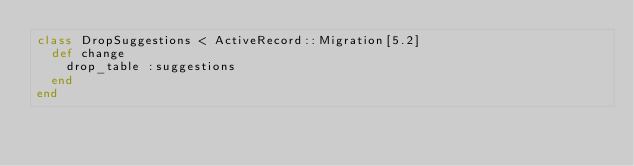<code> <loc_0><loc_0><loc_500><loc_500><_Ruby_>class DropSuggestions < ActiveRecord::Migration[5.2]
  def change
    drop_table :suggestions
  end
end
</code> 